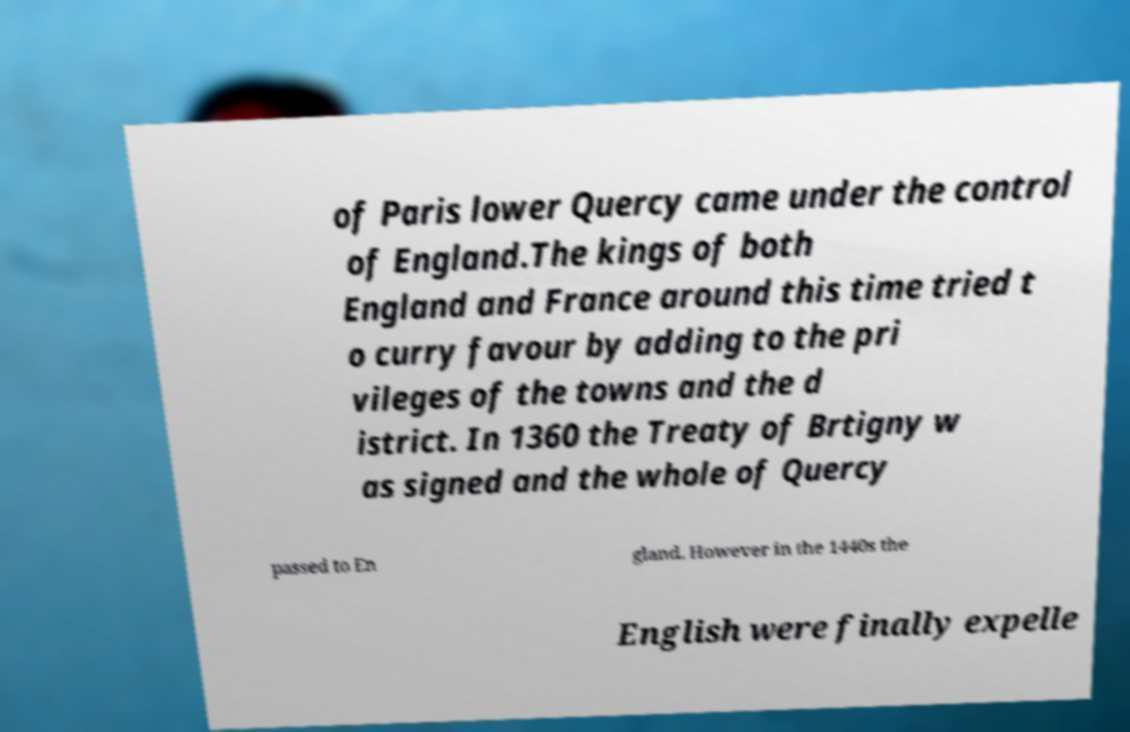Can you read and provide the text displayed in the image?This photo seems to have some interesting text. Can you extract and type it out for me? of Paris lower Quercy came under the control of England.The kings of both England and France around this time tried t o curry favour by adding to the pri vileges of the towns and the d istrict. In 1360 the Treaty of Brtigny w as signed and the whole of Quercy passed to En gland. However in the 1440s the English were finally expelle 